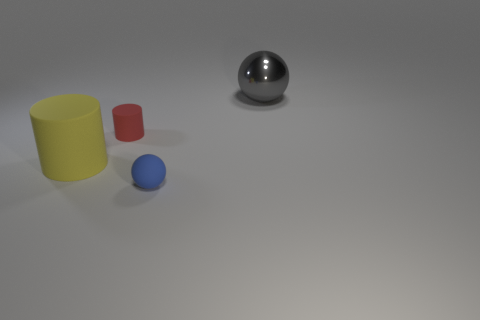Add 3 brown objects. How many objects exist? 7 Add 2 big gray metallic things. How many big gray metallic things exist? 3 Subtract 0 brown balls. How many objects are left? 4 Subtract all small red metal spheres. Subtract all large gray balls. How many objects are left? 3 Add 1 blue rubber things. How many blue rubber things are left? 2 